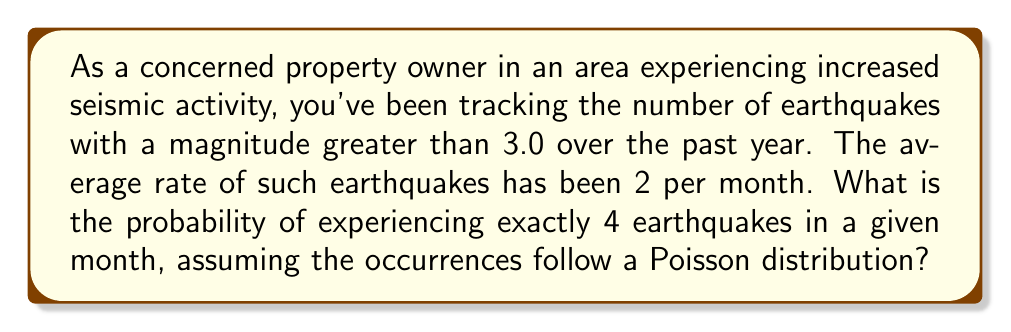Can you solve this math problem? To solve this problem, we'll use the Poisson distribution formula:

$$P(X = k) = \frac{e^{-\lambda} \lambda^k}{k!}$$

Where:
- $\lambda$ is the average rate of events in the given time period
- $k$ is the number of events we're interested in
- $e$ is Euler's number (approximately 2.71828)

Given:
- $\lambda = 2$ (average of 2 earthquakes per month)
- $k = 4$ (we're interested in exactly 4 earthquakes)

Let's substitute these values into the formula:

$$P(X = 4) = \frac{e^{-2} 2^4}{4!}$$

Step 1: Calculate $e^{-2}$
$$e^{-2} \approx 0.1353$$

Step 2: Calculate $2^4$
$$2^4 = 16$$

Step 3: Calculate $4!$
$$4! = 4 \times 3 \times 2 \times 1 = 24$$

Step 4: Substitute these values into the formula
$$P(X = 4) = \frac{0.1353 \times 16}{24}$$

Step 5: Perform the calculation
$$P(X = 4) = \frac{2.1648}{24} \approx 0.0902$$

Therefore, the probability of experiencing exactly 4 earthquakes in a given month is approximately 0.0902 or 9.02%.
Answer: 0.0902 (or 9.02%) 